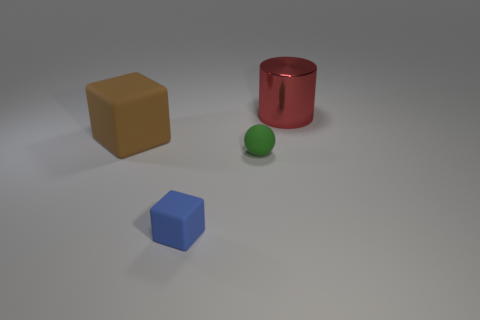Add 2 matte objects. How many objects exist? 6 Subtract 1 blocks. How many blocks are left? 1 Subtract all blue cubes. How many blue spheres are left? 0 Subtract all large red cylinders. Subtract all large red shiny cylinders. How many objects are left? 2 Add 4 small rubber things. How many small rubber things are left? 6 Add 1 tiny gray shiny balls. How many tiny gray shiny balls exist? 1 Subtract all blue cubes. How many cubes are left? 1 Subtract 0 cyan cylinders. How many objects are left? 4 Subtract all cylinders. How many objects are left? 3 Subtract all cyan balls. Subtract all cyan blocks. How many balls are left? 1 